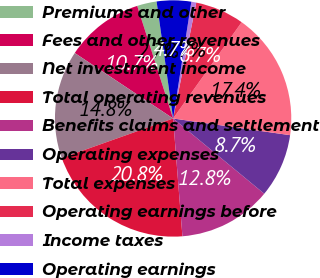<chart> <loc_0><loc_0><loc_500><loc_500><pie_chart><fcel>Premiums and other<fcel>Fees and other revenues<fcel>Net investment income<fcel>Total operating revenues<fcel>Benefits claims and settlement<fcel>Operating expenses<fcel>Total expenses<fcel>Operating earnings before<fcel>Income taxes<fcel>Operating earnings<nl><fcel>2.68%<fcel>10.74%<fcel>14.78%<fcel>20.82%<fcel>12.76%<fcel>8.73%<fcel>17.41%<fcel>6.71%<fcel>0.67%<fcel>4.7%<nl></chart> 